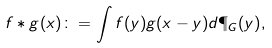<formula> <loc_0><loc_0><loc_500><loc_500>f \ast g ( x ) \colon = \int { f ( y ) g ( x - y ) d \P _ { G } ( y ) } ,</formula> 